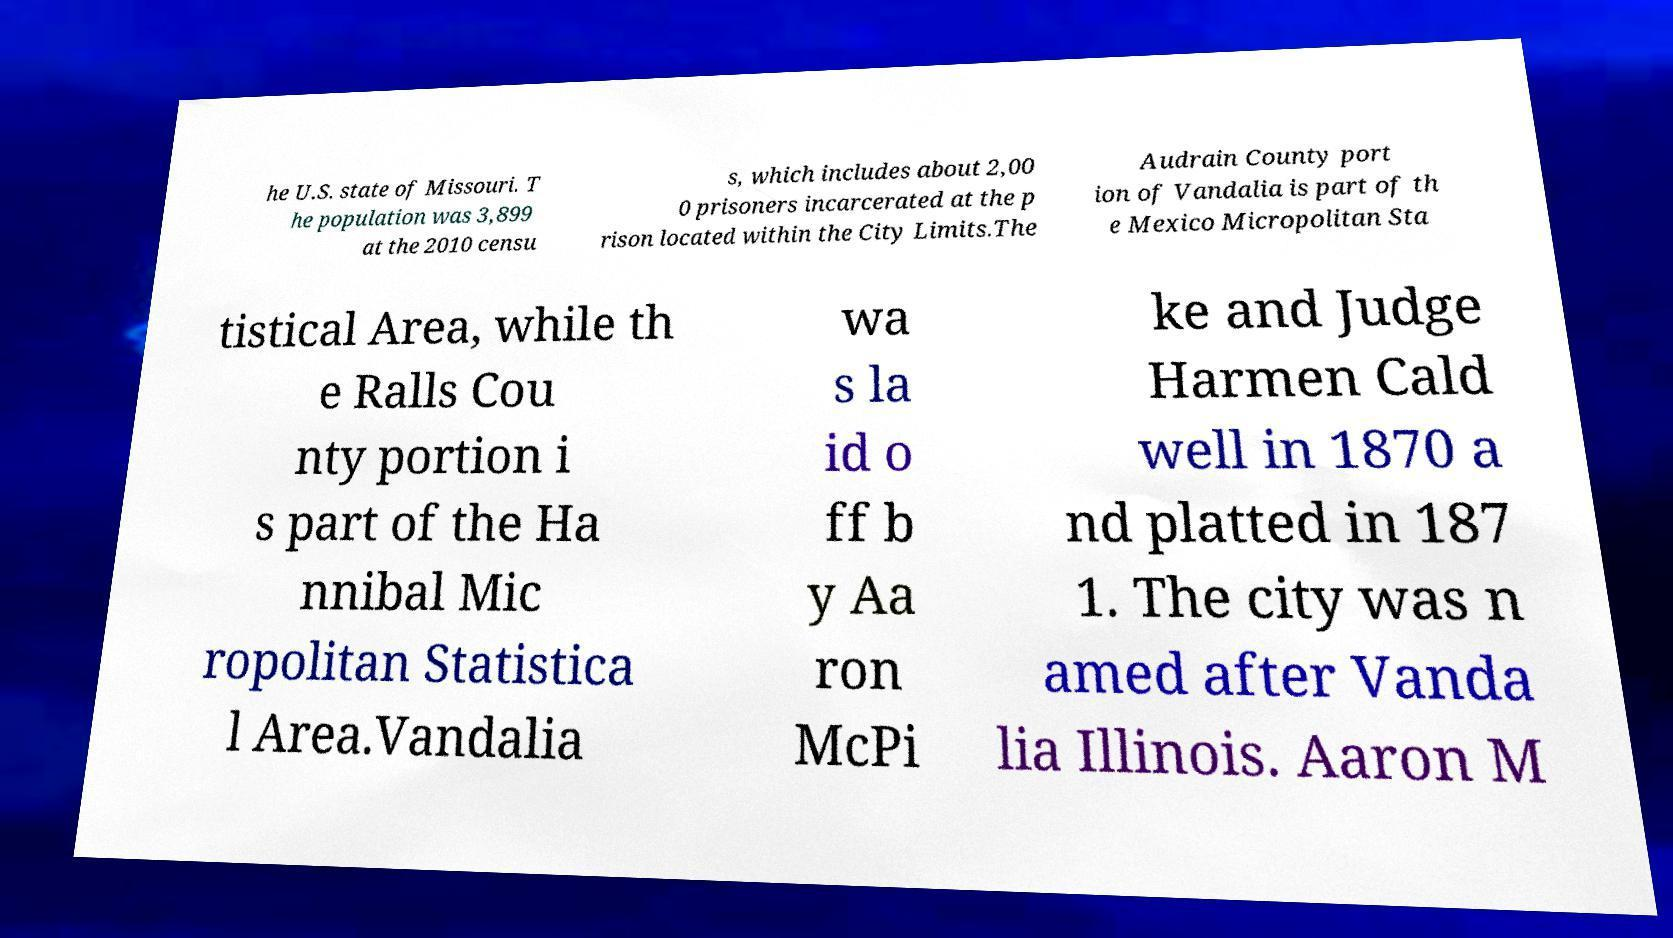Please read and relay the text visible in this image. What does it say? he U.S. state of Missouri. T he population was 3,899 at the 2010 censu s, which includes about 2,00 0 prisoners incarcerated at the p rison located within the City Limits.The Audrain County port ion of Vandalia is part of th e Mexico Micropolitan Sta tistical Area, while th e Ralls Cou nty portion i s part of the Ha nnibal Mic ropolitan Statistica l Area.Vandalia wa s la id o ff b y Aa ron McPi ke and Judge Harmen Cald well in 1870 a nd platted in 187 1. The city was n amed after Vanda lia Illinois. Aaron M 